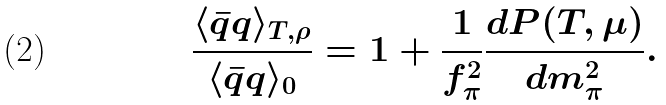<formula> <loc_0><loc_0><loc_500><loc_500>\frac { \langle \bar { q } q \rangle _ { T , \rho } } { \langle \bar { q } q \rangle _ { 0 } } = 1 + \frac { 1 } { f _ { \pi } ^ { 2 } } \frac { d P ( T , \mu ) } { d m _ { \pi } ^ { 2 } } .</formula> 